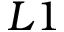Convert formula to latex. <formula><loc_0><loc_0><loc_500><loc_500>{ L 1 }</formula> 